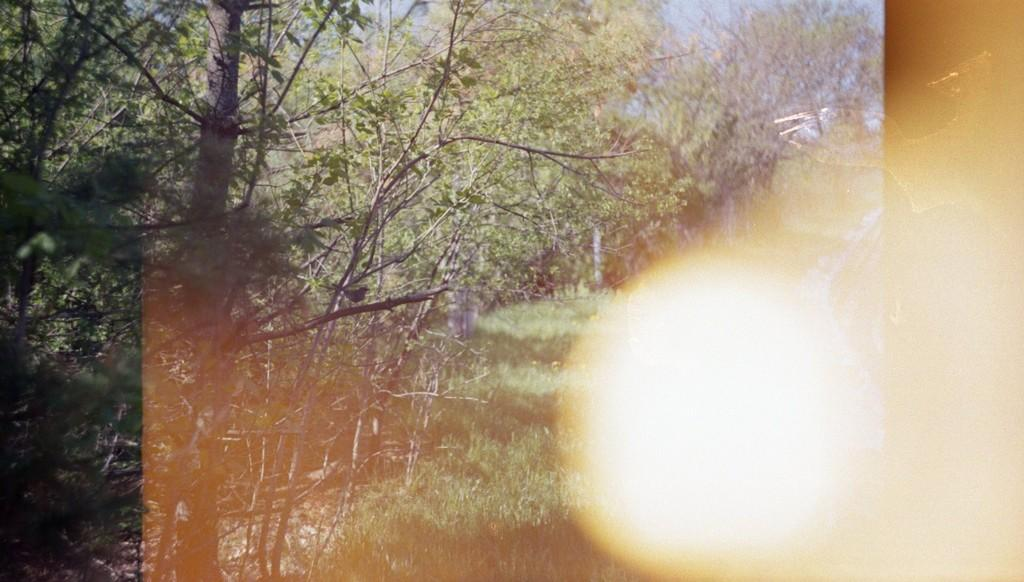What type of vegetation can be seen in the image? There are trees and plants in the image. What part of the natural environment is visible in the image? The sky is visible in the image. What type of yak can be seen grazing in the image? There is no yak present in the image; it only features trees, plants, and the sky. 